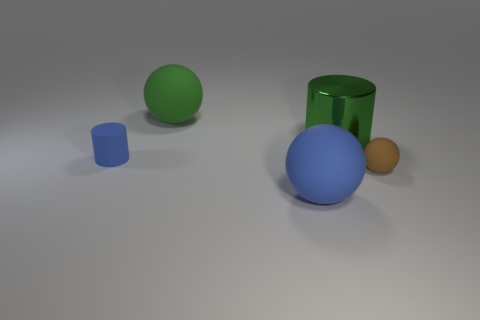Is the number of matte things to the right of the big blue object less than the number of large green cylinders?
Your answer should be compact. No. Do the big blue ball and the green sphere have the same material?
Your answer should be very brief. Yes. What number of objects are blue rubber things or green balls?
Your answer should be compact. 3. How many brown objects are made of the same material as the big green sphere?
Your answer should be very brief. 1. There is a blue matte thing that is the same shape as the brown object; what size is it?
Your answer should be compact. Large. Are there any blue objects left of the big green ball?
Your response must be concise. Yes. What is the material of the green cylinder?
Your answer should be very brief. Metal. Does the large rubber object that is in front of the green matte ball have the same color as the matte cylinder?
Give a very brief answer. Yes. The other tiny object that is the same shape as the green matte object is what color?
Keep it short and to the point. Brown. There is a large green thing on the left side of the green metal object; what is its material?
Your answer should be compact. Rubber. 